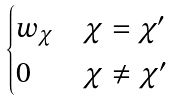<formula> <loc_0><loc_0><loc_500><loc_500>\begin{cases} w _ { \chi } & \chi = \chi ^ { \prime } \\ 0 & \chi \neq \chi ^ { \prime } \end{cases}</formula> 